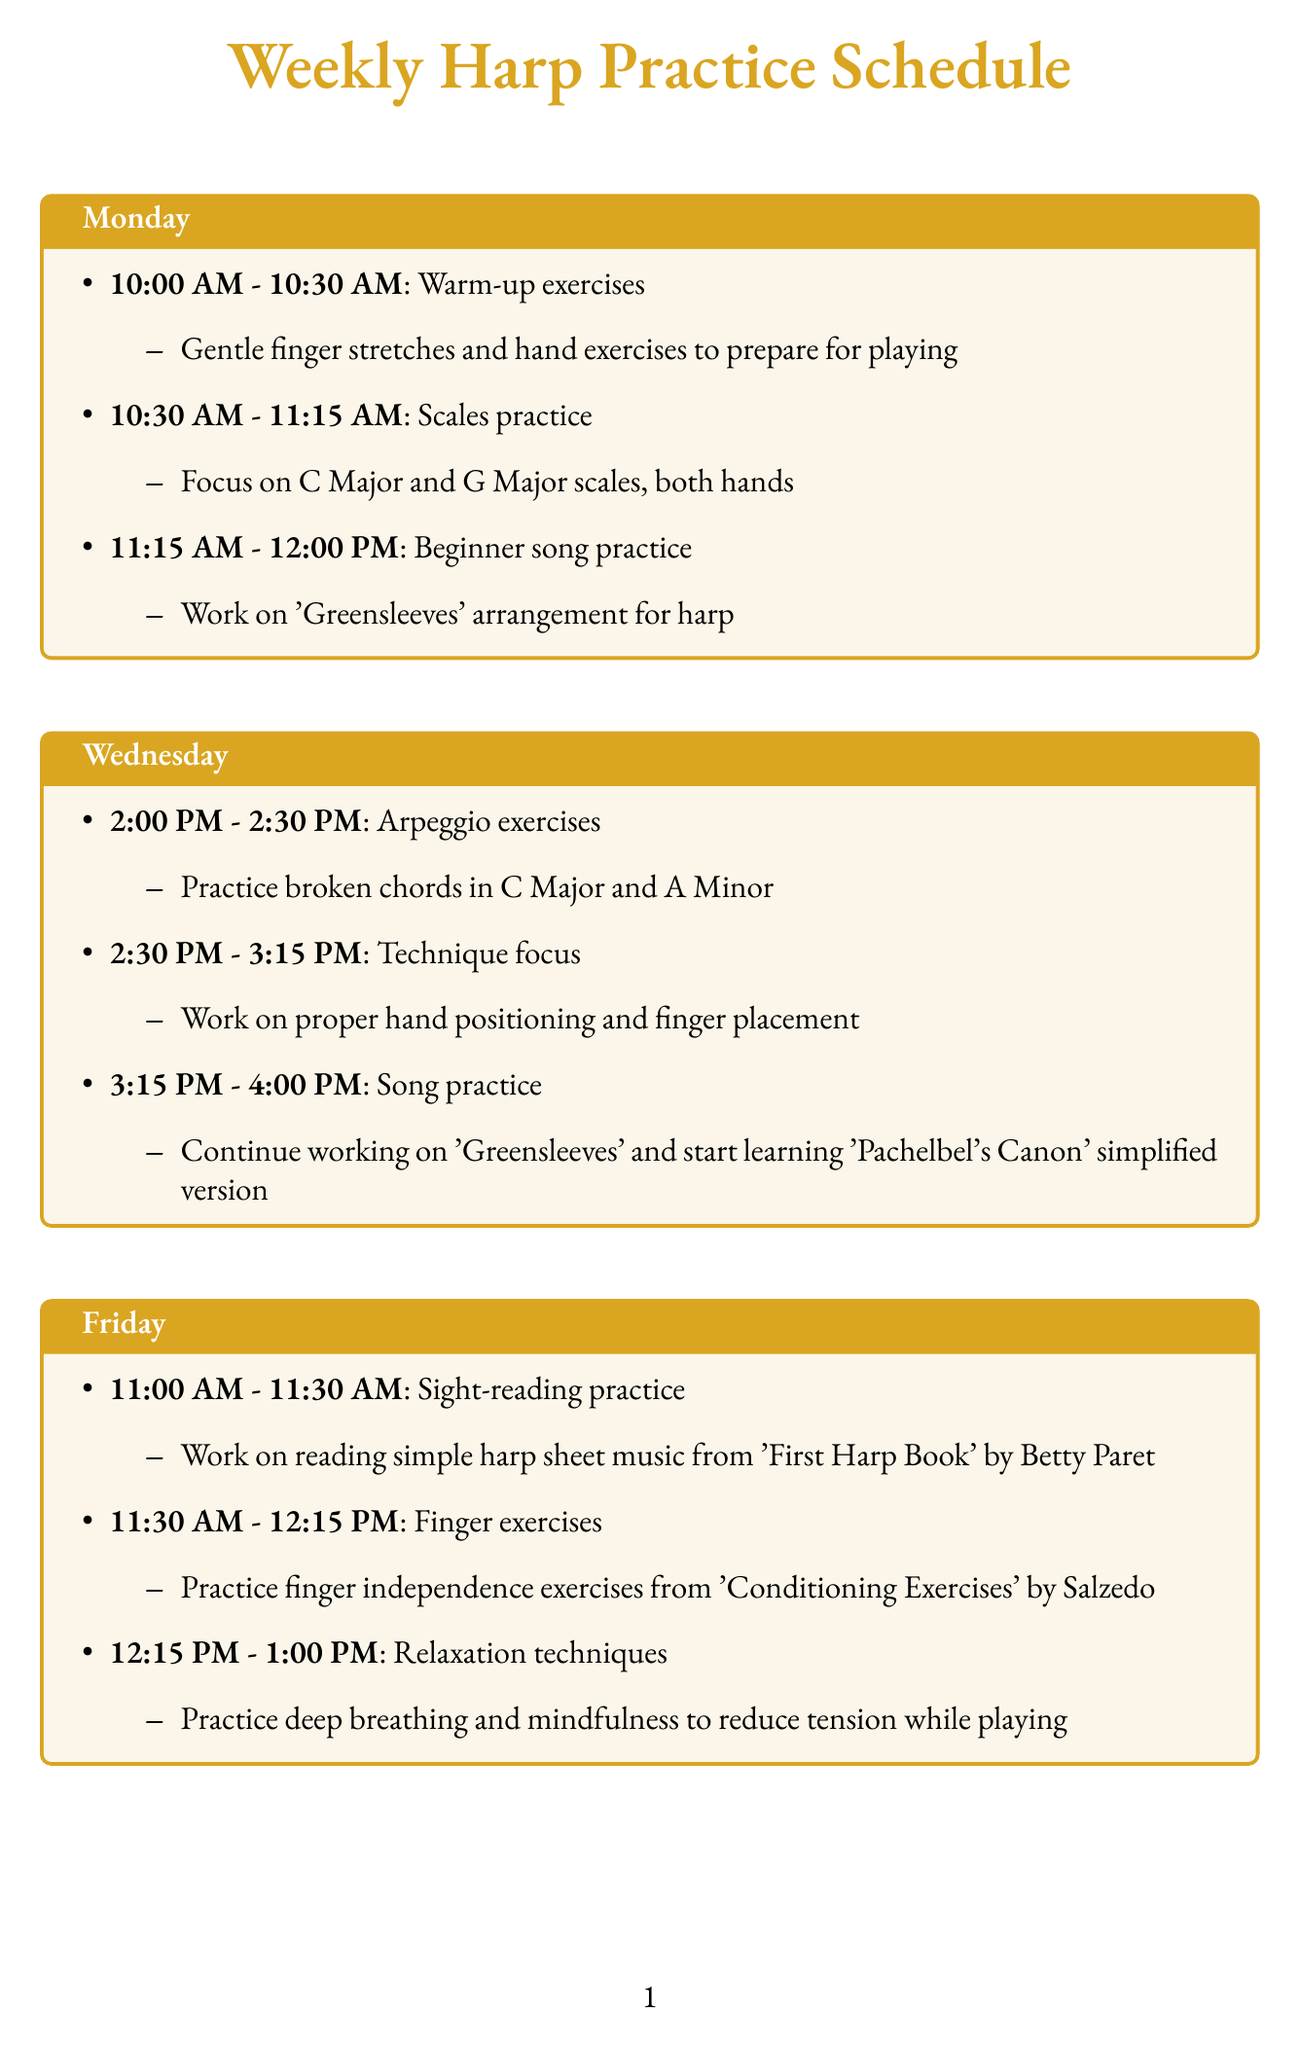What activity is scheduled from 10:00 AM to 10:30 AM on Monday? The document specifies "Warm-up exercises" as the activity for that time slot on Monday.
Answer: Warm-up exercises Which songs are covered in the Wednesday practice session? According to the schedule, the songs mentioned for Wednesday are "Greensleeves" and "Pachelbel's Canon".
Answer: Greensleeves, Pachelbel's Canon What time does Finger exercises start on Friday? The schedule indicates that Finger exercises begin at 11:30 AM on Friday.
Answer: 11:30 AM How many total practice slots are scheduled for Saturday? There are three distinct practice slots listed for Saturday in the document.
Answer: Three What is the primary focus during the "Technique focus" slot on Wednesday? The document states the focus is on "proper hand positioning and finger placement".
Answer: Proper hand positioning and finger placement What adaptive consideration is mentioned for joint stiffness? The document suggests incorporating "more frequent breaks and gentle stretching between practice sessions" to address joint stiffness.
Answer: More frequent breaks and gentle stretching What is the duration of the "Sight-reading practice" on Friday? The schedule states that Sight-reading practice lasts for 30 minutes, from 11:00 AM to 11:30 AM.
Answer: 30 minutes Which resource is recommended for learning proper harp care? The document recommends a video tutorial by Sylvia Woods on YouTube for harp maintenance.
Answer: Video tutorial by Sylvia Woods on YouTube 